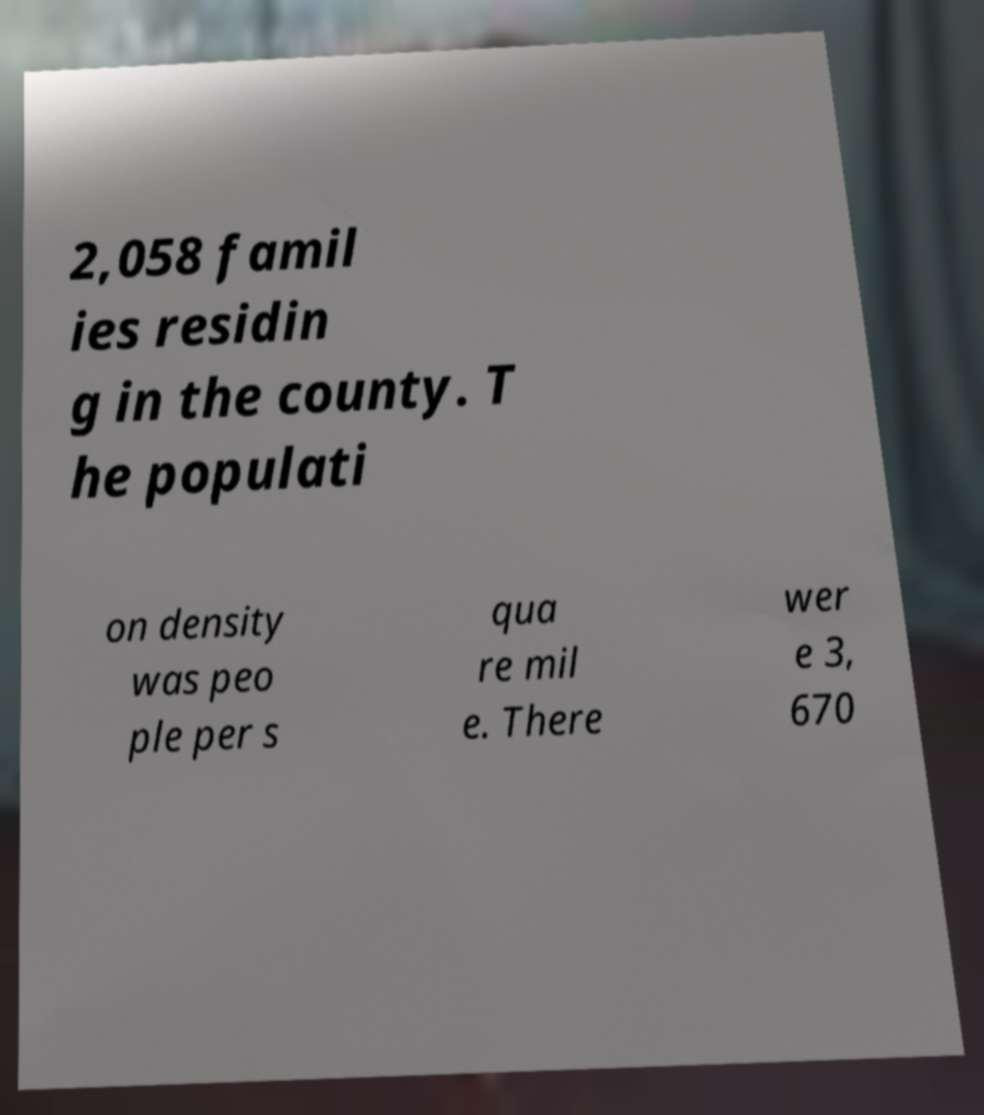There's text embedded in this image that I need extracted. Can you transcribe it verbatim? 2,058 famil ies residin g in the county. T he populati on density was peo ple per s qua re mil e. There wer e 3, 670 